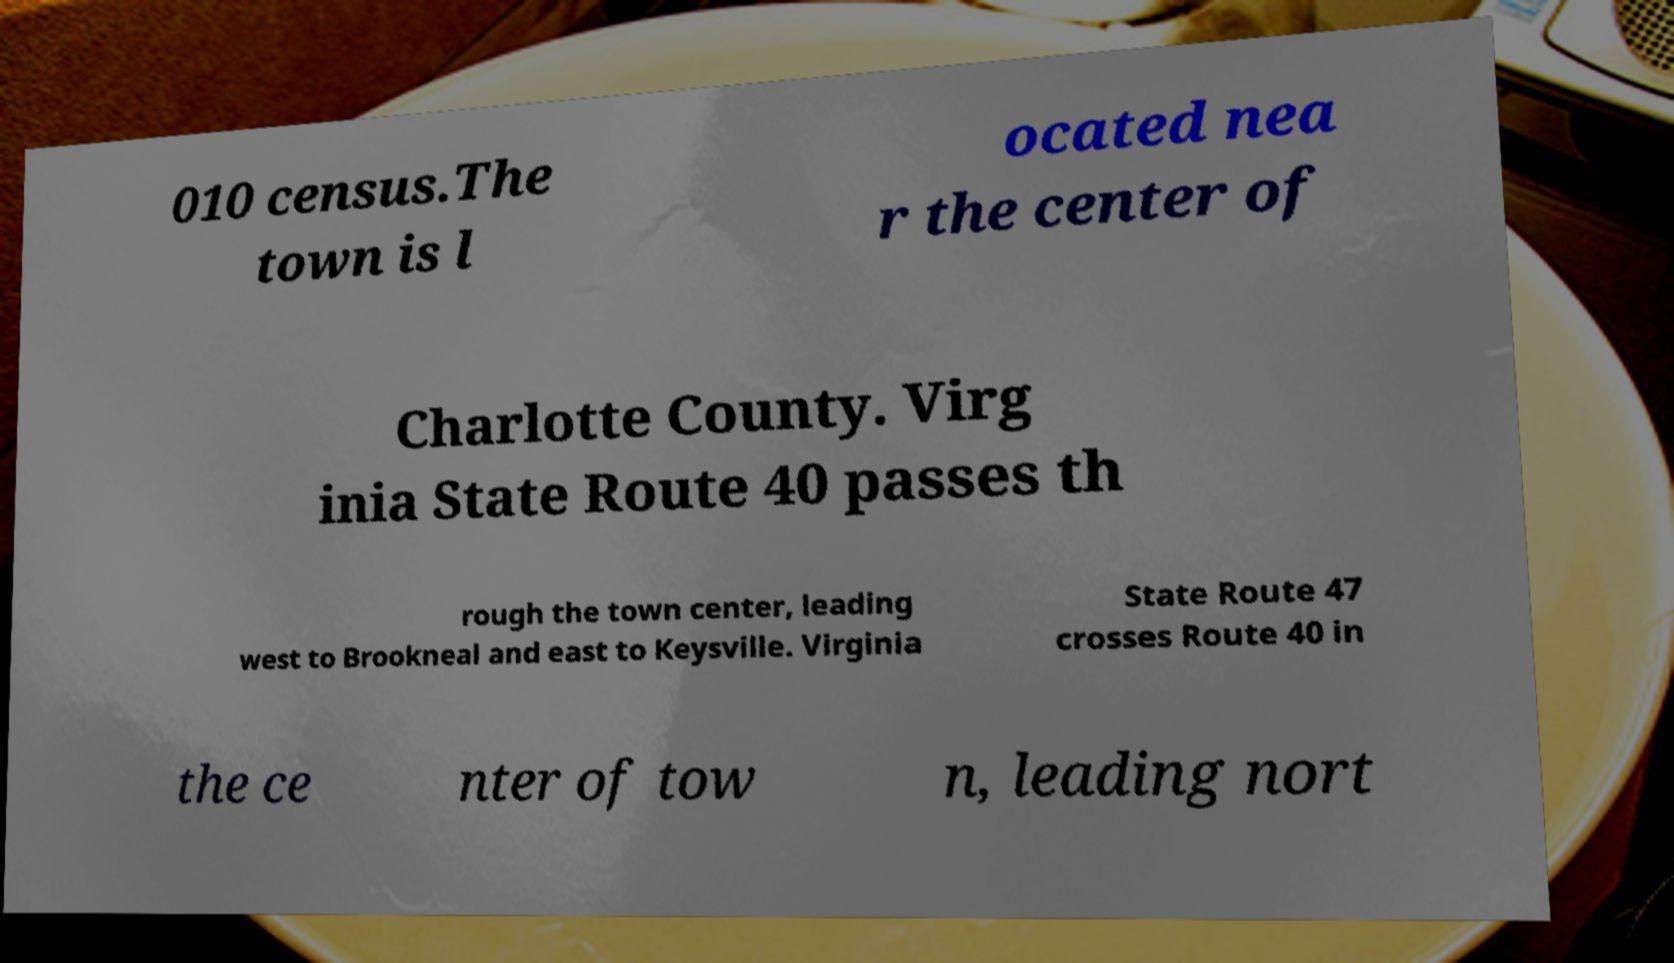For documentation purposes, I need the text within this image transcribed. Could you provide that? 010 census.The town is l ocated nea r the center of Charlotte County. Virg inia State Route 40 passes th rough the town center, leading west to Brookneal and east to Keysville. Virginia State Route 47 crosses Route 40 in the ce nter of tow n, leading nort 